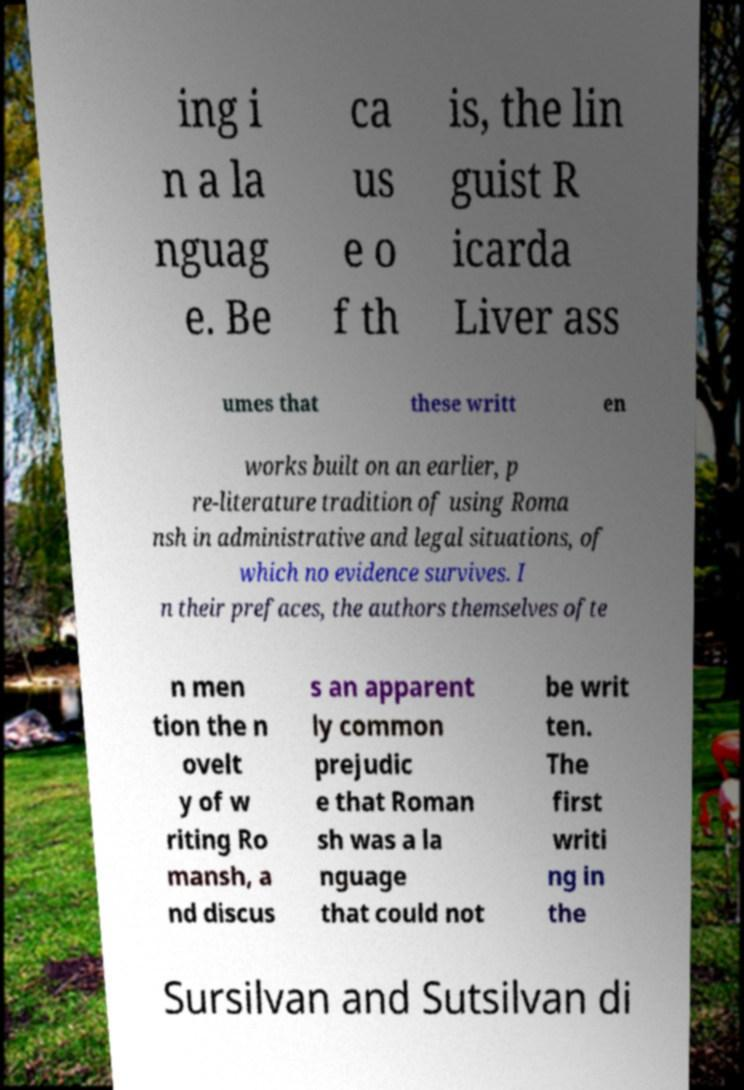I need the written content from this picture converted into text. Can you do that? ing i n a la nguag e. Be ca us e o f th is, the lin guist R icarda Liver ass umes that these writt en works built on an earlier, p re-literature tradition of using Roma nsh in administrative and legal situations, of which no evidence survives. I n their prefaces, the authors themselves ofte n men tion the n ovelt y of w riting Ro mansh, a nd discus s an apparent ly common prejudic e that Roman sh was a la nguage that could not be writ ten. The first writi ng in the Sursilvan and Sutsilvan di 